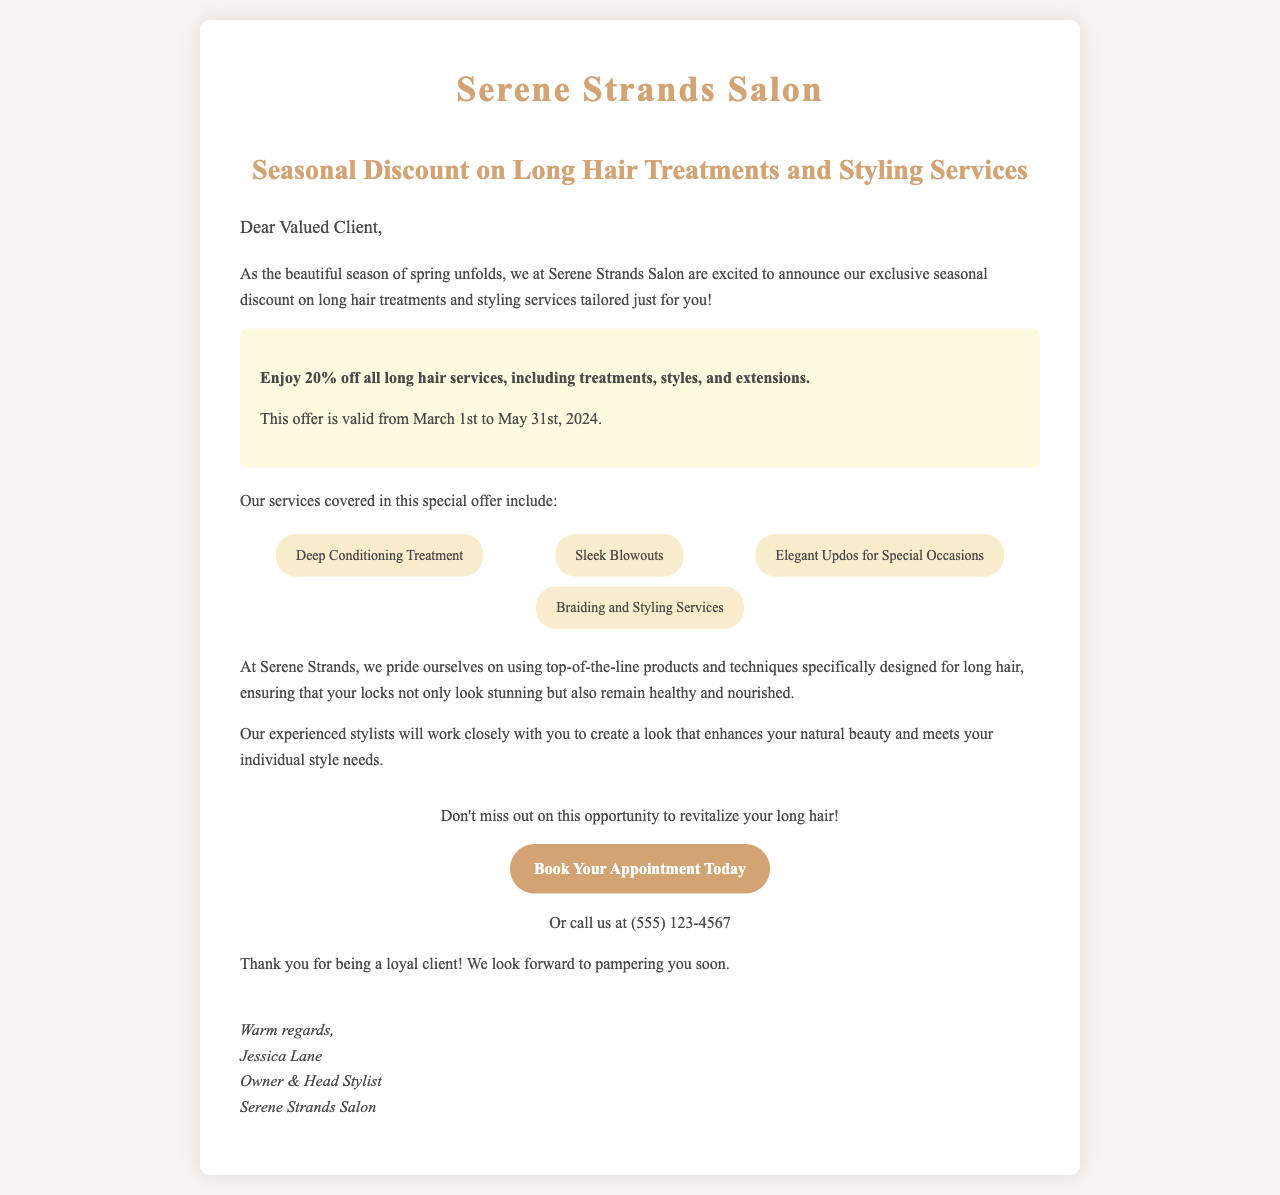what is the name of the salon? The document clearly states the name of the salon at the top, which is "Serene Strands Salon."
Answer: Serene Strands Salon what is the discount percentage offered? The highlighted section mentions the discount being offered on long hair services, which is 20%.
Answer: 20% when does the promotional offer end? The document specifies that the offer is valid until May 31st, 2024.
Answer: May 31st, 2024 what type of services are included in the discount? The document lists specific long hair services such as "Deep Conditioning Treatment," "Sleek Blowouts," and others.
Answer: Deep Conditioning Treatment, Sleek Blowouts, Elegant Updos for Special Occasions, Braiding and Styling Services who is the owner of the salon? The signature at the end of the document provides the name of the owner, which is Jessica Lane.
Answer: Jessica Lane what is the contact method to book an appointment? The document states that clients can either book online or call the salon, providing the phone number for contact.
Answer: (555) 123-4567 why should clients consider this offer? The content highlights the quality of products and techniques used, along with the impact on hair health and beauty, making it appealing.
Answer: To revitalize their long hair what is the occasion for this promotional offer? The letter mentions that the offer is tied to the season of spring, indicating the timing for the promotion.
Answer: Spring 